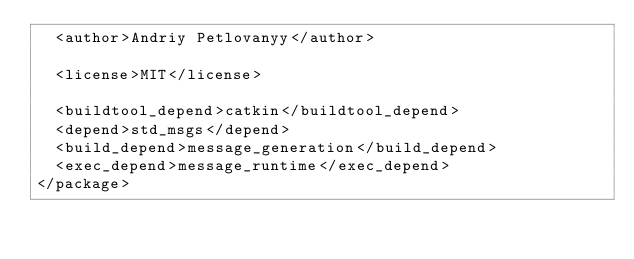<code> <loc_0><loc_0><loc_500><loc_500><_XML_>  <author>Andriy Petlovanyy</author>

  <license>MIT</license>

  <buildtool_depend>catkin</buildtool_depend>
  <depend>std_msgs</depend>
  <build_depend>message_generation</build_depend>
  <exec_depend>message_runtime</exec_depend>
</package>
</code> 